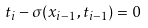<formula> <loc_0><loc_0><loc_500><loc_500>t _ { i } - \sigma ( x _ { i - 1 } , t _ { i - 1 } ) = 0</formula> 